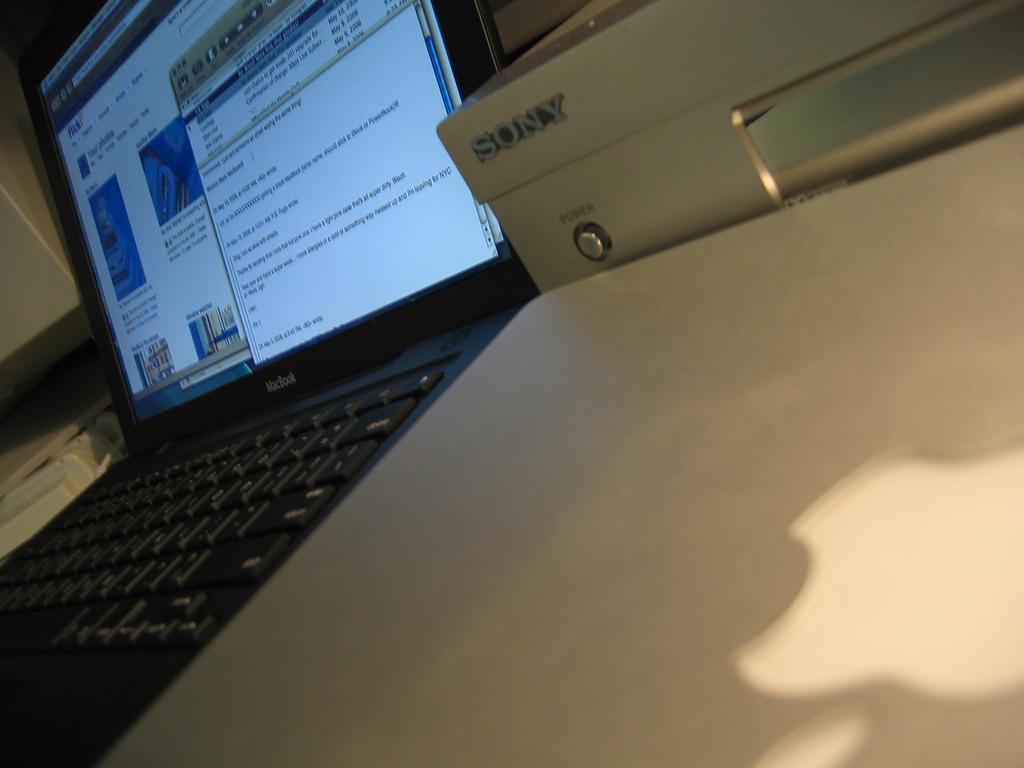How would you summarize this image in a sentence or two? In this image there is a laptop. There is text displayed on the screen of the laptop. Beside to it there is a machine. There is text on the machine. 